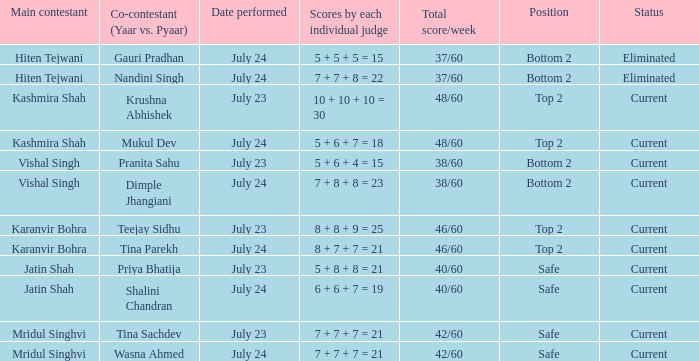Who is the primary competitor with scores by each separate judge of 8 + 7 + 7 = 21? Karanvir Bohra. 